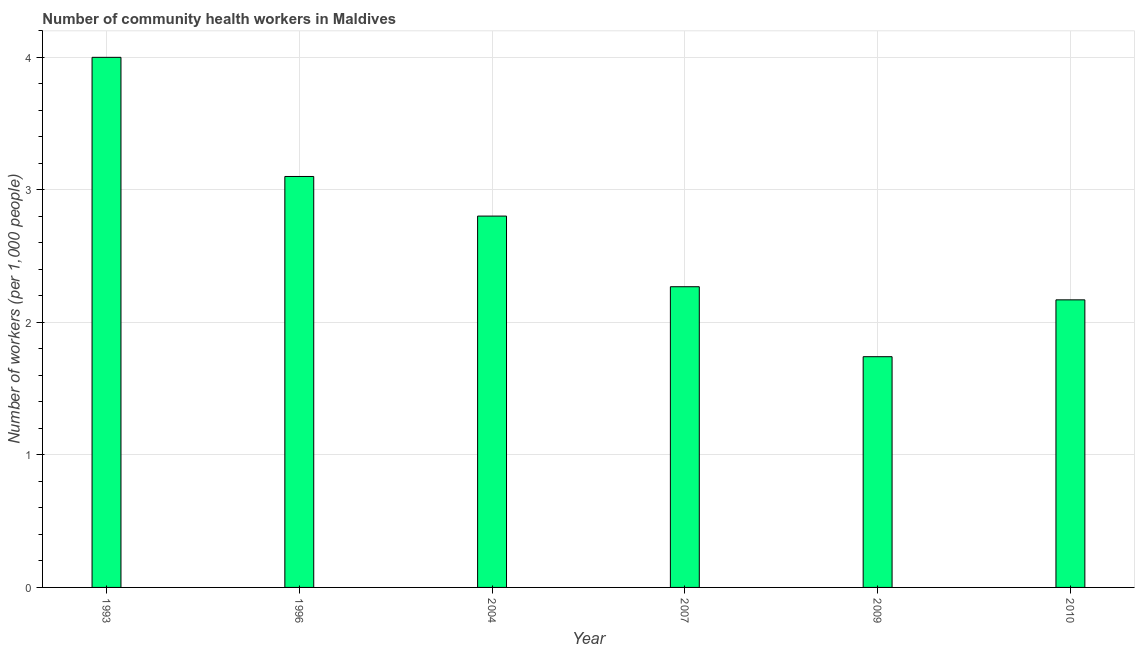Does the graph contain any zero values?
Keep it short and to the point. No. What is the title of the graph?
Ensure brevity in your answer.  Number of community health workers in Maldives. What is the label or title of the X-axis?
Ensure brevity in your answer.  Year. What is the label or title of the Y-axis?
Make the answer very short. Number of workers (per 1,0 people). What is the number of community health workers in 2009?
Provide a short and direct response. 1.74. Across all years, what is the maximum number of community health workers?
Your answer should be very brief. 4. Across all years, what is the minimum number of community health workers?
Give a very brief answer. 1.74. What is the sum of the number of community health workers?
Ensure brevity in your answer.  16.08. What is the average number of community health workers per year?
Give a very brief answer. 2.68. What is the median number of community health workers?
Keep it short and to the point. 2.54. In how many years, is the number of community health workers greater than 2.8 ?
Make the answer very short. 3. What is the ratio of the number of community health workers in 1993 to that in 2004?
Offer a very short reply. 1.43. Is the difference between the number of community health workers in 2007 and 2009 greater than the difference between any two years?
Provide a short and direct response. No. What is the difference between the highest and the second highest number of community health workers?
Your answer should be compact. 0.9. Is the sum of the number of community health workers in 2007 and 2009 greater than the maximum number of community health workers across all years?
Keep it short and to the point. Yes. What is the difference between the highest and the lowest number of community health workers?
Give a very brief answer. 2.26. In how many years, is the number of community health workers greater than the average number of community health workers taken over all years?
Keep it short and to the point. 3. How many bars are there?
Your response must be concise. 6. How many years are there in the graph?
Give a very brief answer. 6. What is the Number of workers (per 1,000 people) of 1993?
Give a very brief answer. 4. What is the Number of workers (per 1,000 people) of 1996?
Your answer should be very brief. 3.1. What is the Number of workers (per 1,000 people) in 2004?
Provide a succinct answer. 2.8. What is the Number of workers (per 1,000 people) in 2007?
Your answer should be compact. 2.27. What is the Number of workers (per 1,000 people) in 2009?
Give a very brief answer. 1.74. What is the Number of workers (per 1,000 people) of 2010?
Your answer should be compact. 2.17. What is the difference between the Number of workers (per 1,000 people) in 1993 and 1996?
Your answer should be very brief. 0.9. What is the difference between the Number of workers (per 1,000 people) in 1993 and 2004?
Provide a short and direct response. 1.2. What is the difference between the Number of workers (per 1,000 people) in 1993 and 2007?
Provide a short and direct response. 1.73. What is the difference between the Number of workers (per 1,000 people) in 1993 and 2009?
Provide a succinct answer. 2.26. What is the difference between the Number of workers (per 1,000 people) in 1993 and 2010?
Make the answer very short. 1.83. What is the difference between the Number of workers (per 1,000 people) in 1996 and 2004?
Provide a succinct answer. 0.3. What is the difference between the Number of workers (per 1,000 people) in 1996 and 2007?
Ensure brevity in your answer.  0.83. What is the difference between the Number of workers (per 1,000 people) in 1996 and 2009?
Provide a short and direct response. 1.36. What is the difference between the Number of workers (per 1,000 people) in 2004 and 2007?
Make the answer very short. 0.53. What is the difference between the Number of workers (per 1,000 people) in 2004 and 2009?
Give a very brief answer. 1.06. What is the difference between the Number of workers (per 1,000 people) in 2004 and 2010?
Make the answer very short. 0.63. What is the difference between the Number of workers (per 1,000 people) in 2007 and 2009?
Your answer should be very brief. 0.53. What is the difference between the Number of workers (per 1,000 people) in 2007 and 2010?
Offer a very short reply. 0.1. What is the difference between the Number of workers (per 1,000 people) in 2009 and 2010?
Provide a short and direct response. -0.43. What is the ratio of the Number of workers (per 1,000 people) in 1993 to that in 1996?
Provide a short and direct response. 1.29. What is the ratio of the Number of workers (per 1,000 people) in 1993 to that in 2004?
Your answer should be compact. 1.43. What is the ratio of the Number of workers (per 1,000 people) in 1993 to that in 2007?
Provide a short and direct response. 1.76. What is the ratio of the Number of workers (per 1,000 people) in 1993 to that in 2009?
Your answer should be very brief. 2.3. What is the ratio of the Number of workers (per 1,000 people) in 1993 to that in 2010?
Make the answer very short. 1.84. What is the ratio of the Number of workers (per 1,000 people) in 1996 to that in 2004?
Provide a succinct answer. 1.11. What is the ratio of the Number of workers (per 1,000 people) in 1996 to that in 2007?
Your answer should be very brief. 1.37. What is the ratio of the Number of workers (per 1,000 people) in 1996 to that in 2009?
Give a very brief answer. 1.78. What is the ratio of the Number of workers (per 1,000 people) in 1996 to that in 2010?
Offer a very short reply. 1.43. What is the ratio of the Number of workers (per 1,000 people) in 2004 to that in 2007?
Your answer should be compact. 1.24. What is the ratio of the Number of workers (per 1,000 people) in 2004 to that in 2009?
Provide a short and direct response. 1.61. What is the ratio of the Number of workers (per 1,000 people) in 2004 to that in 2010?
Offer a terse response. 1.29. What is the ratio of the Number of workers (per 1,000 people) in 2007 to that in 2009?
Your answer should be compact. 1.3. What is the ratio of the Number of workers (per 1,000 people) in 2007 to that in 2010?
Provide a succinct answer. 1.05. What is the ratio of the Number of workers (per 1,000 people) in 2009 to that in 2010?
Your answer should be very brief. 0.8. 